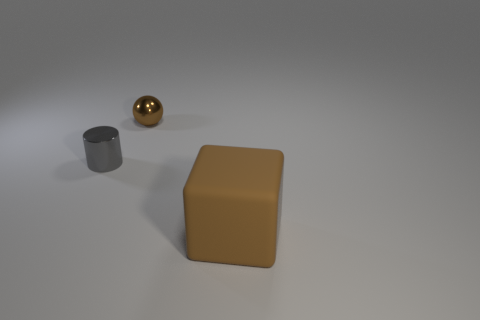Is there anything else that is the same size as the matte object?
Keep it short and to the point. No. Are there more cylinders than small brown matte spheres?
Your response must be concise. Yes. Is the color of the shiny ball the same as the big matte thing?
Provide a short and direct response. Yes. How many things are either small cubes or brown things behind the cylinder?
Ensure brevity in your answer.  1. How many other objects are the same shape as the big matte object?
Ensure brevity in your answer.  0. Is the number of large brown matte cubes behind the cube less than the number of things that are right of the tiny gray shiny thing?
Ensure brevity in your answer.  Yes. Is there any other thing that has the same material as the large brown cube?
Your response must be concise. No. There is a thing that is made of the same material as the gray cylinder; what shape is it?
Make the answer very short. Sphere. Is there any other thing of the same color as the small sphere?
Your answer should be compact. Yes. There is a metallic object to the right of the metallic object that is in front of the tiny brown object; what color is it?
Your answer should be very brief. Brown. 